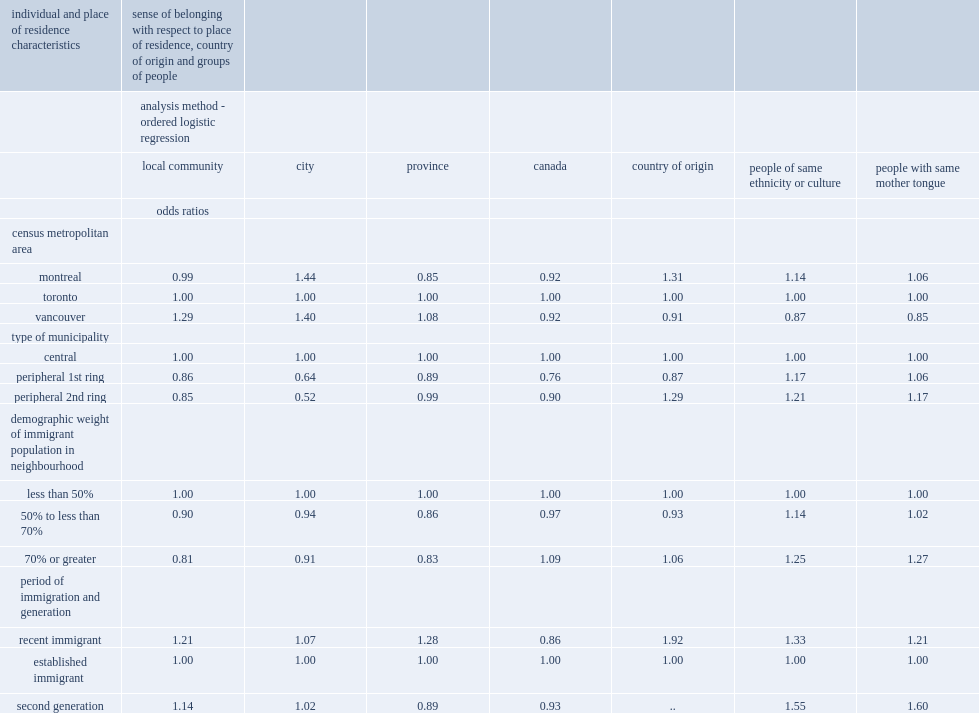Can you parse all the data within this table? {'header': ['individual and place of residence characteristics', 'sense of belonging with respect to place of residence, country of origin and groups of people', '', '', '', '', '', ''], 'rows': [['', 'analysis method - ordered logistic regression', '', '', '', '', '', ''], ['', 'local community', 'city', 'province', 'canada', 'country of origin', 'people of same ethnicity or culture', 'people with same mother tongue'], ['', 'odds ratios', '', '', '', '', '', ''], ['census metropolitan area', '', '', '', '', '', '', ''], ['montreal', '0.99', '1.44', '0.85', '0.92', '1.31', '1.14', '1.06'], ['toronto', '1.00', '1.00', '1.00', '1.00', '1.00', '1.00', '1.00'], ['vancouver', '1.29', '1.40', '1.08', '0.92', '0.91', '0.87', '0.85'], ['type of municipality', '', '', '', '', '', '', ''], ['central', '1.00', '1.00', '1.00', '1.00', '1.00', '1.00', '1.00'], ['peripheral 1st ring', '0.86', '0.64', '0.89', '0.76', '0.87', '1.17', '1.06'], ['peripheral 2nd ring', '0.85', '0.52', '0.99', '0.90', '1.29', '1.21', '1.17'], ['demographic weight of immigrant population in neighbourhood', '', '', '', '', '', '', ''], ['less than 50%', '1.00', '1.00', '1.00', '1.00', '1.00', '1.00', '1.00'], ['50% to less than 70%', '0.90', '0.94', '0.86', '0.97', '0.93', '1.14', '1.02'], ['70% or greater', '0.81', '0.91', '0.83', '1.09', '1.06', '1.25', '1.27'], ['period of immigration and generation', '', '', '', '', '', '', ''], ['recent immigrant', '1.21', '1.07', '1.28', '0.86', '1.92', '1.33', '1.21'], ['established immigrant', '1.00', '1.00', '1.00', '1.00', '1.00', '1.00', '1.00'], ['second generation', '1.14', '1.02', '0.89', '0.93', '..', '1.55', '1.60']]} Which groups of residents show stronger sense of belonging to their town or city, residents of central municipalites or residents of 1st ring peripheral municipalites? Central. Which groups of residents show stronger sense of belonging to their town or city, residents of central municipalites or residents of 2nd ring peripheral municipalites? Central. Which group of respondents were more likely to express a strong sense of belonging to their town or city, residents in the montreal or residents in toronto? Montreal. Which group of respondents were more likely to express a strong sense of belonging to their town or city, residents in vancouver or residents in toronto? Vancouver. 